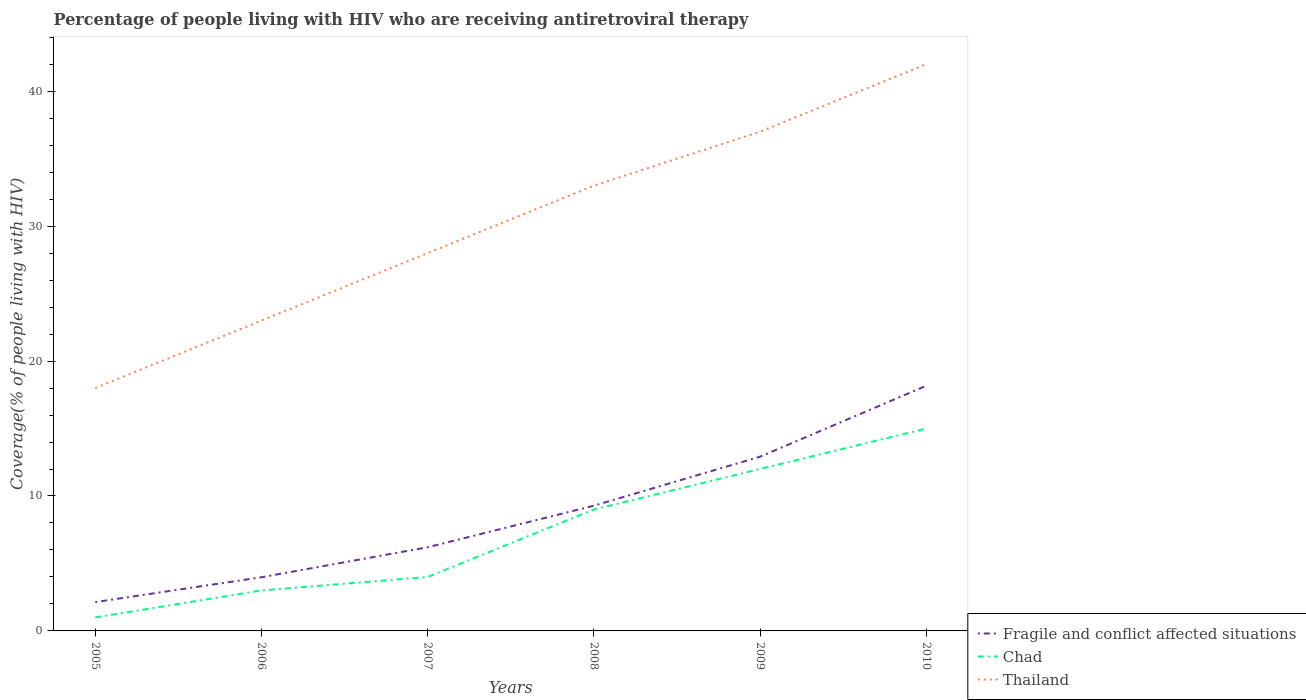Across all years, what is the maximum percentage of the HIV infected people who are receiving antiretroviral therapy in Thailand?
Offer a very short reply. 18. What is the total percentage of the HIV infected people who are receiving antiretroviral therapy in Thailand in the graph?
Provide a succinct answer. -5. What is the difference between the highest and the second highest percentage of the HIV infected people who are receiving antiretroviral therapy in Thailand?
Offer a very short reply. 24. What is the difference between the highest and the lowest percentage of the HIV infected people who are receiving antiretroviral therapy in Fragile and conflict affected situations?
Provide a succinct answer. 3. How many lines are there?
Keep it short and to the point. 3. How many years are there in the graph?
Your answer should be very brief. 6. What is the difference between two consecutive major ticks on the Y-axis?
Your response must be concise. 10. How many legend labels are there?
Provide a short and direct response. 3. How are the legend labels stacked?
Offer a terse response. Vertical. What is the title of the graph?
Keep it short and to the point. Percentage of people living with HIV who are receiving antiretroviral therapy. Does "Belize" appear as one of the legend labels in the graph?
Ensure brevity in your answer.  No. What is the label or title of the Y-axis?
Give a very brief answer. Coverage(% of people living with HIV). What is the Coverage(% of people living with HIV) of Fragile and conflict affected situations in 2005?
Offer a terse response. 2.14. What is the Coverage(% of people living with HIV) in Thailand in 2005?
Make the answer very short. 18. What is the Coverage(% of people living with HIV) in Fragile and conflict affected situations in 2006?
Provide a succinct answer. 3.98. What is the Coverage(% of people living with HIV) in Thailand in 2006?
Your answer should be very brief. 23. What is the Coverage(% of people living with HIV) in Fragile and conflict affected situations in 2007?
Your answer should be compact. 6.2. What is the Coverage(% of people living with HIV) in Thailand in 2007?
Ensure brevity in your answer.  28. What is the Coverage(% of people living with HIV) in Fragile and conflict affected situations in 2008?
Provide a short and direct response. 9.28. What is the Coverage(% of people living with HIV) in Chad in 2008?
Ensure brevity in your answer.  9. What is the Coverage(% of people living with HIV) of Thailand in 2008?
Ensure brevity in your answer.  33. What is the Coverage(% of people living with HIV) in Fragile and conflict affected situations in 2009?
Offer a terse response. 12.91. What is the Coverage(% of people living with HIV) in Chad in 2009?
Offer a terse response. 12. What is the Coverage(% of people living with HIV) of Fragile and conflict affected situations in 2010?
Keep it short and to the point. 18.17. What is the Coverage(% of people living with HIV) in Chad in 2010?
Offer a terse response. 15. Across all years, what is the maximum Coverage(% of people living with HIV) in Fragile and conflict affected situations?
Make the answer very short. 18.17. Across all years, what is the maximum Coverage(% of people living with HIV) of Chad?
Your answer should be very brief. 15. Across all years, what is the maximum Coverage(% of people living with HIV) of Thailand?
Your answer should be very brief. 42. Across all years, what is the minimum Coverage(% of people living with HIV) of Fragile and conflict affected situations?
Provide a short and direct response. 2.14. What is the total Coverage(% of people living with HIV) of Fragile and conflict affected situations in the graph?
Your response must be concise. 52.68. What is the total Coverage(% of people living with HIV) in Chad in the graph?
Provide a short and direct response. 44. What is the total Coverage(% of people living with HIV) in Thailand in the graph?
Ensure brevity in your answer.  181. What is the difference between the Coverage(% of people living with HIV) in Fragile and conflict affected situations in 2005 and that in 2006?
Offer a very short reply. -1.84. What is the difference between the Coverage(% of people living with HIV) of Fragile and conflict affected situations in 2005 and that in 2007?
Provide a short and direct response. -4.06. What is the difference between the Coverage(% of people living with HIV) of Fragile and conflict affected situations in 2005 and that in 2008?
Your answer should be very brief. -7.14. What is the difference between the Coverage(% of people living with HIV) of Chad in 2005 and that in 2008?
Provide a succinct answer. -8. What is the difference between the Coverage(% of people living with HIV) in Thailand in 2005 and that in 2008?
Ensure brevity in your answer.  -15. What is the difference between the Coverage(% of people living with HIV) of Fragile and conflict affected situations in 2005 and that in 2009?
Offer a very short reply. -10.78. What is the difference between the Coverage(% of people living with HIV) in Chad in 2005 and that in 2009?
Your answer should be compact. -11. What is the difference between the Coverage(% of people living with HIV) in Fragile and conflict affected situations in 2005 and that in 2010?
Your answer should be compact. -16.03. What is the difference between the Coverage(% of people living with HIV) in Fragile and conflict affected situations in 2006 and that in 2007?
Provide a short and direct response. -2.22. What is the difference between the Coverage(% of people living with HIV) of Chad in 2006 and that in 2007?
Provide a succinct answer. -1. What is the difference between the Coverage(% of people living with HIV) of Thailand in 2006 and that in 2007?
Your answer should be very brief. -5. What is the difference between the Coverage(% of people living with HIV) of Fragile and conflict affected situations in 2006 and that in 2008?
Your response must be concise. -5.3. What is the difference between the Coverage(% of people living with HIV) in Chad in 2006 and that in 2008?
Give a very brief answer. -6. What is the difference between the Coverage(% of people living with HIV) in Thailand in 2006 and that in 2008?
Offer a terse response. -10. What is the difference between the Coverage(% of people living with HIV) of Fragile and conflict affected situations in 2006 and that in 2009?
Ensure brevity in your answer.  -8.94. What is the difference between the Coverage(% of people living with HIV) in Chad in 2006 and that in 2009?
Your answer should be compact. -9. What is the difference between the Coverage(% of people living with HIV) of Thailand in 2006 and that in 2009?
Provide a short and direct response. -14. What is the difference between the Coverage(% of people living with HIV) of Fragile and conflict affected situations in 2006 and that in 2010?
Provide a succinct answer. -14.19. What is the difference between the Coverage(% of people living with HIV) in Thailand in 2006 and that in 2010?
Provide a succinct answer. -19. What is the difference between the Coverage(% of people living with HIV) in Fragile and conflict affected situations in 2007 and that in 2008?
Keep it short and to the point. -3.08. What is the difference between the Coverage(% of people living with HIV) in Chad in 2007 and that in 2008?
Your response must be concise. -5. What is the difference between the Coverage(% of people living with HIV) in Thailand in 2007 and that in 2008?
Your answer should be compact. -5. What is the difference between the Coverage(% of people living with HIV) of Fragile and conflict affected situations in 2007 and that in 2009?
Your response must be concise. -6.71. What is the difference between the Coverage(% of people living with HIV) in Thailand in 2007 and that in 2009?
Keep it short and to the point. -9. What is the difference between the Coverage(% of people living with HIV) of Fragile and conflict affected situations in 2007 and that in 2010?
Provide a succinct answer. -11.97. What is the difference between the Coverage(% of people living with HIV) of Chad in 2007 and that in 2010?
Make the answer very short. -11. What is the difference between the Coverage(% of people living with HIV) of Fragile and conflict affected situations in 2008 and that in 2009?
Offer a terse response. -3.63. What is the difference between the Coverage(% of people living with HIV) of Chad in 2008 and that in 2009?
Ensure brevity in your answer.  -3. What is the difference between the Coverage(% of people living with HIV) in Thailand in 2008 and that in 2009?
Provide a short and direct response. -4. What is the difference between the Coverage(% of people living with HIV) in Fragile and conflict affected situations in 2008 and that in 2010?
Provide a succinct answer. -8.89. What is the difference between the Coverage(% of people living with HIV) of Thailand in 2008 and that in 2010?
Your answer should be compact. -9. What is the difference between the Coverage(% of people living with HIV) in Fragile and conflict affected situations in 2009 and that in 2010?
Your answer should be very brief. -5.25. What is the difference between the Coverage(% of people living with HIV) in Fragile and conflict affected situations in 2005 and the Coverage(% of people living with HIV) in Chad in 2006?
Give a very brief answer. -0.86. What is the difference between the Coverage(% of people living with HIV) in Fragile and conflict affected situations in 2005 and the Coverage(% of people living with HIV) in Thailand in 2006?
Ensure brevity in your answer.  -20.86. What is the difference between the Coverage(% of people living with HIV) in Fragile and conflict affected situations in 2005 and the Coverage(% of people living with HIV) in Chad in 2007?
Ensure brevity in your answer.  -1.86. What is the difference between the Coverage(% of people living with HIV) of Fragile and conflict affected situations in 2005 and the Coverage(% of people living with HIV) of Thailand in 2007?
Keep it short and to the point. -25.86. What is the difference between the Coverage(% of people living with HIV) in Chad in 2005 and the Coverage(% of people living with HIV) in Thailand in 2007?
Your response must be concise. -27. What is the difference between the Coverage(% of people living with HIV) in Fragile and conflict affected situations in 2005 and the Coverage(% of people living with HIV) in Chad in 2008?
Keep it short and to the point. -6.86. What is the difference between the Coverage(% of people living with HIV) in Fragile and conflict affected situations in 2005 and the Coverage(% of people living with HIV) in Thailand in 2008?
Offer a very short reply. -30.86. What is the difference between the Coverage(% of people living with HIV) in Chad in 2005 and the Coverage(% of people living with HIV) in Thailand in 2008?
Make the answer very short. -32. What is the difference between the Coverage(% of people living with HIV) in Fragile and conflict affected situations in 2005 and the Coverage(% of people living with HIV) in Chad in 2009?
Offer a terse response. -9.86. What is the difference between the Coverage(% of people living with HIV) of Fragile and conflict affected situations in 2005 and the Coverage(% of people living with HIV) of Thailand in 2009?
Offer a terse response. -34.86. What is the difference between the Coverage(% of people living with HIV) in Chad in 2005 and the Coverage(% of people living with HIV) in Thailand in 2009?
Your answer should be compact. -36. What is the difference between the Coverage(% of people living with HIV) of Fragile and conflict affected situations in 2005 and the Coverage(% of people living with HIV) of Chad in 2010?
Your response must be concise. -12.86. What is the difference between the Coverage(% of people living with HIV) of Fragile and conflict affected situations in 2005 and the Coverage(% of people living with HIV) of Thailand in 2010?
Provide a succinct answer. -39.86. What is the difference between the Coverage(% of people living with HIV) of Chad in 2005 and the Coverage(% of people living with HIV) of Thailand in 2010?
Your answer should be compact. -41. What is the difference between the Coverage(% of people living with HIV) of Fragile and conflict affected situations in 2006 and the Coverage(% of people living with HIV) of Chad in 2007?
Offer a terse response. -0.02. What is the difference between the Coverage(% of people living with HIV) of Fragile and conflict affected situations in 2006 and the Coverage(% of people living with HIV) of Thailand in 2007?
Make the answer very short. -24.02. What is the difference between the Coverage(% of people living with HIV) of Fragile and conflict affected situations in 2006 and the Coverage(% of people living with HIV) of Chad in 2008?
Ensure brevity in your answer.  -5.02. What is the difference between the Coverage(% of people living with HIV) of Fragile and conflict affected situations in 2006 and the Coverage(% of people living with HIV) of Thailand in 2008?
Provide a short and direct response. -29.02. What is the difference between the Coverage(% of people living with HIV) of Fragile and conflict affected situations in 2006 and the Coverage(% of people living with HIV) of Chad in 2009?
Your answer should be very brief. -8.02. What is the difference between the Coverage(% of people living with HIV) in Fragile and conflict affected situations in 2006 and the Coverage(% of people living with HIV) in Thailand in 2009?
Provide a short and direct response. -33.02. What is the difference between the Coverage(% of people living with HIV) in Chad in 2006 and the Coverage(% of people living with HIV) in Thailand in 2009?
Your answer should be very brief. -34. What is the difference between the Coverage(% of people living with HIV) of Fragile and conflict affected situations in 2006 and the Coverage(% of people living with HIV) of Chad in 2010?
Give a very brief answer. -11.02. What is the difference between the Coverage(% of people living with HIV) in Fragile and conflict affected situations in 2006 and the Coverage(% of people living with HIV) in Thailand in 2010?
Offer a terse response. -38.02. What is the difference between the Coverage(% of people living with HIV) of Chad in 2006 and the Coverage(% of people living with HIV) of Thailand in 2010?
Your response must be concise. -39. What is the difference between the Coverage(% of people living with HIV) of Fragile and conflict affected situations in 2007 and the Coverage(% of people living with HIV) of Chad in 2008?
Your response must be concise. -2.8. What is the difference between the Coverage(% of people living with HIV) of Fragile and conflict affected situations in 2007 and the Coverage(% of people living with HIV) of Thailand in 2008?
Give a very brief answer. -26.8. What is the difference between the Coverage(% of people living with HIV) in Chad in 2007 and the Coverage(% of people living with HIV) in Thailand in 2008?
Keep it short and to the point. -29. What is the difference between the Coverage(% of people living with HIV) in Fragile and conflict affected situations in 2007 and the Coverage(% of people living with HIV) in Chad in 2009?
Provide a short and direct response. -5.8. What is the difference between the Coverage(% of people living with HIV) of Fragile and conflict affected situations in 2007 and the Coverage(% of people living with HIV) of Thailand in 2009?
Your answer should be very brief. -30.8. What is the difference between the Coverage(% of people living with HIV) in Chad in 2007 and the Coverage(% of people living with HIV) in Thailand in 2009?
Provide a succinct answer. -33. What is the difference between the Coverage(% of people living with HIV) in Fragile and conflict affected situations in 2007 and the Coverage(% of people living with HIV) in Chad in 2010?
Provide a succinct answer. -8.8. What is the difference between the Coverage(% of people living with HIV) in Fragile and conflict affected situations in 2007 and the Coverage(% of people living with HIV) in Thailand in 2010?
Provide a succinct answer. -35.8. What is the difference between the Coverage(% of people living with HIV) of Chad in 2007 and the Coverage(% of people living with HIV) of Thailand in 2010?
Offer a very short reply. -38. What is the difference between the Coverage(% of people living with HIV) in Fragile and conflict affected situations in 2008 and the Coverage(% of people living with HIV) in Chad in 2009?
Provide a short and direct response. -2.72. What is the difference between the Coverage(% of people living with HIV) in Fragile and conflict affected situations in 2008 and the Coverage(% of people living with HIV) in Thailand in 2009?
Make the answer very short. -27.72. What is the difference between the Coverage(% of people living with HIV) of Chad in 2008 and the Coverage(% of people living with HIV) of Thailand in 2009?
Provide a short and direct response. -28. What is the difference between the Coverage(% of people living with HIV) of Fragile and conflict affected situations in 2008 and the Coverage(% of people living with HIV) of Chad in 2010?
Your answer should be very brief. -5.72. What is the difference between the Coverage(% of people living with HIV) in Fragile and conflict affected situations in 2008 and the Coverage(% of people living with HIV) in Thailand in 2010?
Provide a short and direct response. -32.72. What is the difference between the Coverage(% of people living with HIV) of Chad in 2008 and the Coverage(% of people living with HIV) of Thailand in 2010?
Ensure brevity in your answer.  -33. What is the difference between the Coverage(% of people living with HIV) in Fragile and conflict affected situations in 2009 and the Coverage(% of people living with HIV) in Chad in 2010?
Offer a very short reply. -2.09. What is the difference between the Coverage(% of people living with HIV) in Fragile and conflict affected situations in 2009 and the Coverage(% of people living with HIV) in Thailand in 2010?
Your response must be concise. -29.09. What is the average Coverage(% of people living with HIV) of Fragile and conflict affected situations per year?
Ensure brevity in your answer.  8.78. What is the average Coverage(% of people living with HIV) in Chad per year?
Ensure brevity in your answer.  7.33. What is the average Coverage(% of people living with HIV) of Thailand per year?
Provide a short and direct response. 30.17. In the year 2005, what is the difference between the Coverage(% of people living with HIV) in Fragile and conflict affected situations and Coverage(% of people living with HIV) in Chad?
Give a very brief answer. 1.14. In the year 2005, what is the difference between the Coverage(% of people living with HIV) of Fragile and conflict affected situations and Coverage(% of people living with HIV) of Thailand?
Make the answer very short. -15.86. In the year 2006, what is the difference between the Coverage(% of people living with HIV) in Fragile and conflict affected situations and Coverage(% of people living with HIV) in Thailand?
Offer a very short reply. -19.02. In the year 2006, what is the difference between the Coverage(% of people living with HIV) in Chad and Coverage(% of people living with HIV) in Thailand?
Make the answer very short. -20. In the year 2007, what is the difference between the Coverage(% of people living with HIV) of Fragile and conflict affected situations and Coverage(% of people living with HIV) of Chad?
Your response must be concise. 2.2. In the year 2007, what is the difference between the Coverage(% of people living with HIV) in Fragile and conflict affected situations and Coverage(% of people living with HIV) in Thailand?
Your response must be concise. -21.8. In the year 2007, what is the difference between the Coverage(% of people living with HIV) of Chad and Coverage(% of people living with HIV) of Thailand?
Ensure brevity in your answer.  -24. In the year 2008, what is the difference between the Coverage(% of people living with HIV) of Fragile and conflict affected situations and Coverage(% of people living with HIV) of Chad?
Ensure brevity in your answer.  0.28. In the year 2008, what is the difference between the Coverage(% of people living with HIV) of Fragile and conflict affected situations and Coverage(% of people living with HIV) of Thailand?
Provide a short and direct response. -23.72. In the year 2009, what is the difference between the Coverage(% of people living with HIV) of Fragile and conflict affected situations and Coverage(% of people living with HIV) of Chad?
Offer a very short reply. 0.91. In the year 2009, what is the difference between the Coverage(% of people living with HIV) in Fragile and conflict affected situations and Coverage(% of people living with HIV) in Thailand?
Provide a short and direct response. -24.09. In the year 2010, what is the difference between the Coverage(% of people living with HIV) in Fragile and conflict affected situations and Coverage(% of people living with HIV) in Chad?
Give a very brief answer. 3.17. In the year 2010, what is the difference between the Coverage(% of people living with HIV) of Fragile and conflict affected situations and Coverage(% of people living with HIV) of Thailand?
Offer a terse response. -23.83. In the year 2010, what is the difference between the Coverage(% of people living with HIV) of Chad and Coverage(% of people living with HIV) of Thailand?
Provide a short and direct response. -27. What is the ratio of the Coverage(% of people living with HIV) of Fragile and conflict affected situations in 2005 to that in 2006?
Offer a terse response. 0.54. What is the ratio of the Coverage(% of people living with HIV) in Thailand in 2005 to that in 2006?
Provide a short and direct response. 0.78. What is the ratio of the Coverage(% of people living with HIV) in Fragile and conflict affected situations in 2005 to that in 2007?
Provide a short and direct response. 0.34. What is the ratio of the Coverage(% of people living with HIV) in Chad in 2005 to that in 2007?
Keep it short and to the point. 0.25. What is the ratio of the Coverage(% of people living with HIV) of Thailand in 2005 to that in 2007?
Your response must be concise. 0.64. What is the ratio of the Coverage(% of people living with HIV) of Fragile and conflict affected situations in 2005 to that in 2008?
Ensure brevity in your answer.  0.23. What is the ratio of the Coverage(% of people living with HIV) of Chad in 2005 to that in 2008?
Make the answer very short. 0.11. What is the ratio of the Coverage(% of people living with HIV) of Thailand in 2005 to that in 2008?
Keep it short and to the point. 0.55. What is the ratio of the Coverage(% of people living with HIV) of Fragile and conflict affected situations in 2005 to that in 2009?
Ensure brevity in your answer.  0.17. What is the ratio of the Coverage(% of people living with HIV) in Chad in 2005 to that in 2009?
Your response must be concise. 0.08. What is the ratio of the Coverage(% of people living with HIV) of Thailand in 2005 to that in 2009?
Make the answer very short. 0.49. What is the ratio of the Coverage(% of people living with HIV) in Fragile and conflict affected situations in 2005 to that in 2010?
Your response must be concise. 0.12. What is the ratio of the Coverage(% of people living with HIV) in Chad in 2005 to that in 2010?
Offer a terse response. 0.07. What is the ratio of the Coverage(% of people living with HIV) in Thailand in 2005 to that in 2010?
Your response must be concise. 0.43. What is the ratio of the Coverage(% of people living with HIV) of Fragile and conflict affected situations in 2006 to that in 2007?
Give a very brief answer. 0.64. What is the ratio of the Coverage(% of people living with HIV) in Chad in 2006 to that in 2007?
Offer a terse response. 0.75. What is the ratio of the Coverage(% of people living with HIV) in Thailand in 2006 to that in 2007?
Keep it short and to the point. 0.82. What is the ratio of the Coverage(% of people living with HIV) of Fragile and conflict affected situations in 2006 to that in 2008?
Offer a very short reply. 0.43. What is the ratio of the Coverage(% of people living with HIV) of Thailand in 2006 to that in 2008?
Your response must be concise. 0.7. What is the ratio of the Coverage(% of people living with HIV) of Fragile and conflict affected situations in 2006 to that in 2009?
Offer a very short reply. 0.31. What is the ratio of the Coverage(% of people living with HIV) in Chad in 2006 to that in 2009?
Provide a succinct answer. 0.25. What is the ratio of the Coverage(% of people living with HIV) of Thailand in 2006 to that in 2009?
Ensure brevity in your answer.  0.62. What is the ratio of the Coverage(% of people living with HIV) of Fragile and conflict affected situations in 2006 to that in 2010?
Your answer should be very brief. 0.22. What is the ratio of the Coverage(% of people living with HIV) in Chad in 2006 to that in 2010?
Offer a very short reply. 0.2. What is the ratio of the Coverage(% of people living with HIV) in Thailand in 2006 to that in 2010?
Provide a short and direct response. 0.55. What is the ratio of the Coverage(% of people living with HIV) of Fragile and conflict affected situations in 2007 to that in 2008?
Your answer should be very brief. 0.67. What is the ratio of the Coverage(% of people living with HIV) in Chad in 2007 to that in 2008?
Provide a short and direct response. 0.44. What is the ratio of the Coverage(% of people living with HIV) in Thailand in 2007 to that in 2008?
Offer a very short reply. 0.85. What is the ratio of the Coverage(% of people living with HIV) of Fragile and conflict affected situations in 2007 to that in 2009?
Ensure brevity in your answer.  0.48. What is the ratio of the Coverage(% of people living with HIV) in Chad in 2007 to that in 2009?
Your response must be concise. 0.33. What is the ratio of the Coverage(% of people living with HIV) of Thailand in 2007 to that in 2009?
Offer a terse response. 0.76. What is the ratio of the Coverage(% of people living with HIV) in Fragile and conflict affected situations in 2007 to that in 2010?
Offer a very short reply. 0.34. What is the ratio of the Coverage(% of people living with HIV) in Chad in 2007 to that in 2010?
Offer a very short reply. 0.27. What is the ratio of the Coverage(% of people living with HIV) in Thailand in 2007 to that in 2010?
Offer a very short reply. 0.67. What is the ratio of the Coverage(% of people living with HIV) of Fragile and conflict affected situations in 2008 to that in 2009?
Keep it short and to the point. 0.72. What is the ratio of the Coverage(% of people living with HIV) in Chad in 2008 to that in 2009?
Offer a terse response. 0.75. What is the ratio of the Coverage(% of people living with HIV) of Thailand in 2008 to that in 2009?
Offer a terse response. 0.89. What is the ratio of the Coverage(% of people living with HIV) of Fragile and conflict affected situations in 2008 to that in 2010?
Keep it short and to the point. 0.51. What is the ratio of the Coverage(% of people living with HIV) of Chad in 2008 to that in 2010?
Make the answer very short. 0.6. What is the ratio of the Coverage(% of people living with HIV) in Thailand in 2008 to that in 2010?
Your answer should be very brief. 0.79. What is the ratio of the Coverage(% of people living with HIV) in Fragile and conflict affected situations in 2009 to that in 2010?
Ensure brevity in your answer.  0.71. What is the ratio of the Coverage(% of people living with HIV) of Thailand in 2009 to that in 2010?
Your answer should be very brief. 0.88. What is the difference between the highest and the second highest Coverage(% of people living with HIV) in Fragile and conflict affected situations?
Provide a succinct answer. 5.25. What is the difference between the highest and the lowest Coverage(% of people living with HIV) in Fragile and conflict affected situations?
Offer a terse response. 16.03. What is the difference between the highest and the lowest Coverage(% of people living with HIV) of Chad?
Provide a succinct answer. 14. What is the difference between the highest and the lowest Coverage(% of people living with HIV) of Thailand?
Provide a short and direct response. 24. 